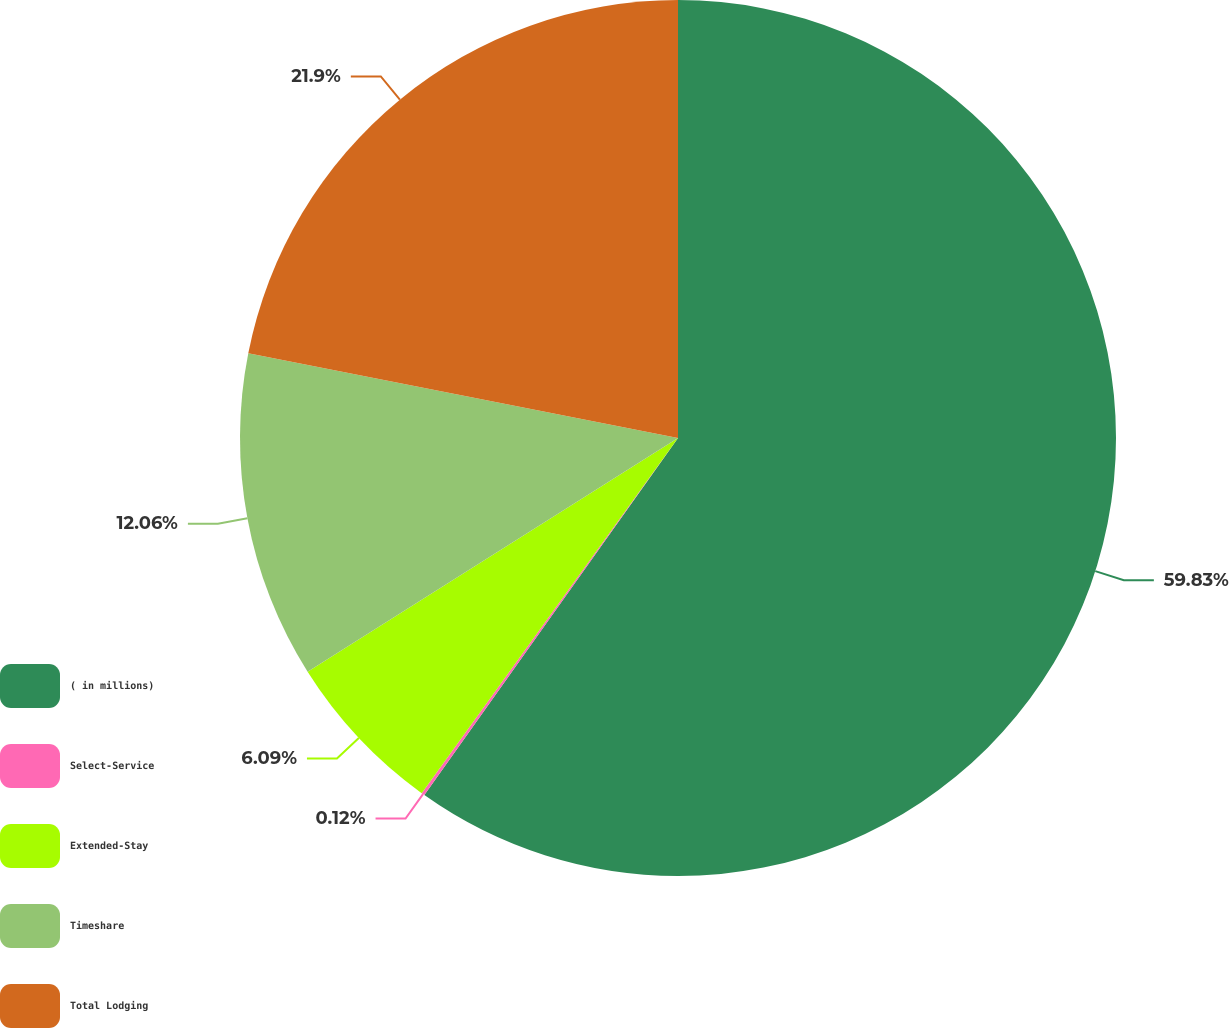Convert chart to OTSL. <chart><loc_0><loc_0><loc_500><loc_500><pie_chart><fcel>( in millions)<fcel>Select-Service<fcel>Extended-Stay<fcel>Timeshare<fcel>Total Lodging<nl><fcel>59.83%<fcel>0.12%<fcel>6.09%<fcel>12.06%<fcel>21.9%<nl></chart> 